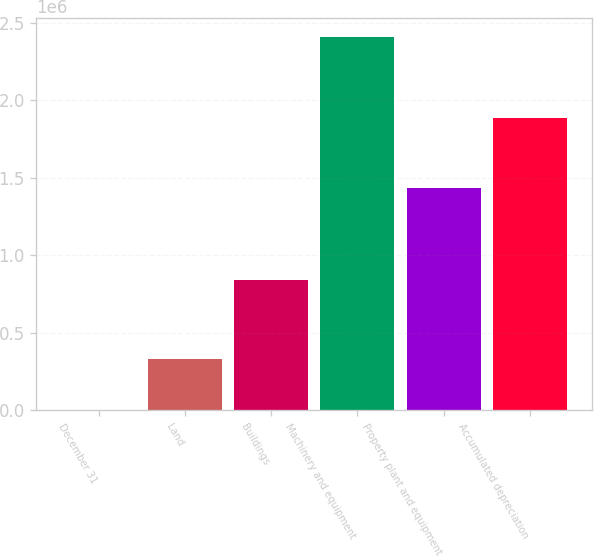Convert chart. <chart><loc_0><loc_0><loc_500><loc_500><bar_chart><fcel>December 31<fcel>Land<fcel>Buildings<fcel>Machinery and equipment<fcel>Property plant and equipment<fcel>Accumulated depreciation<nl><fcel>2010<fcel>334285<fcel>843094<fcel>2.41061e+06<fcel>1.4377e+06<fcel>1.88706e+06<nl></chart> 